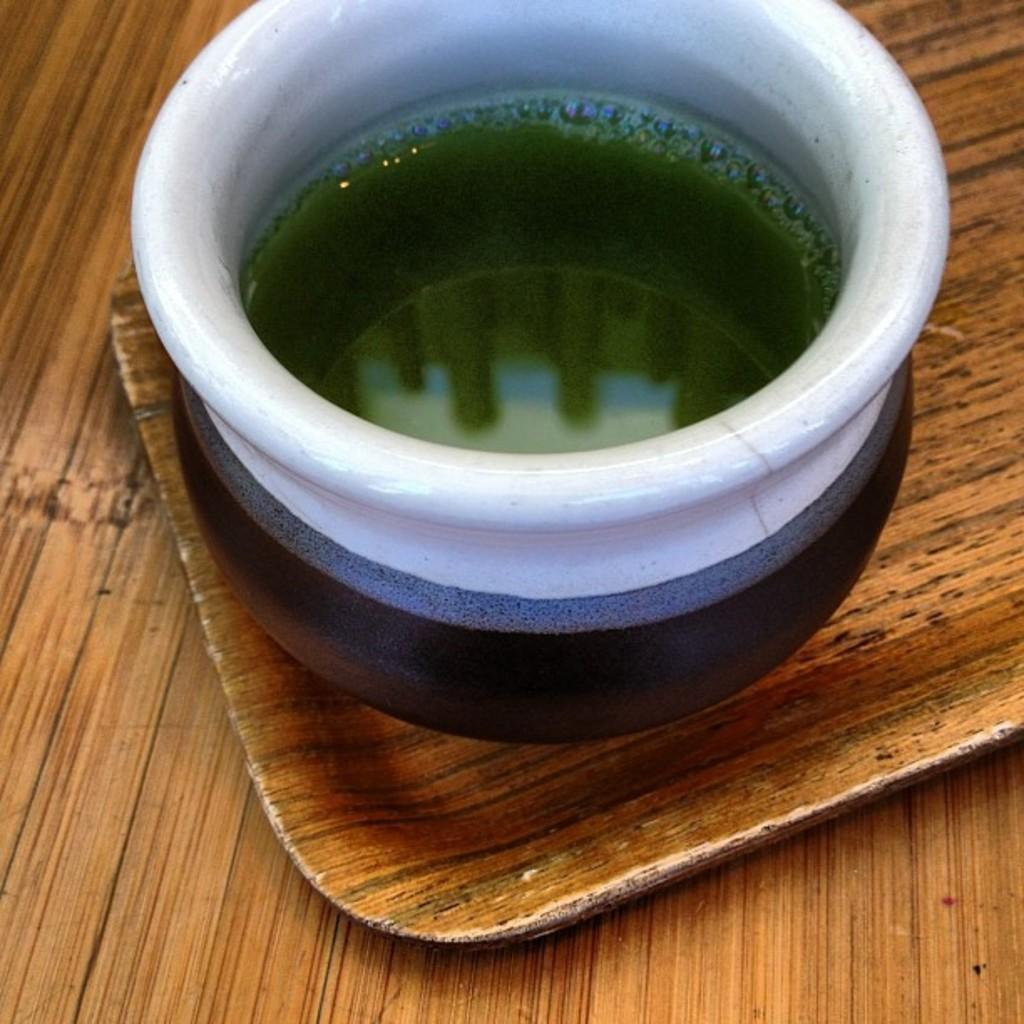Please provide a concise description of this image. In this image, we can see a pot with liquid and bubbles on the wooden tray. Here we can see the wooden surface. 